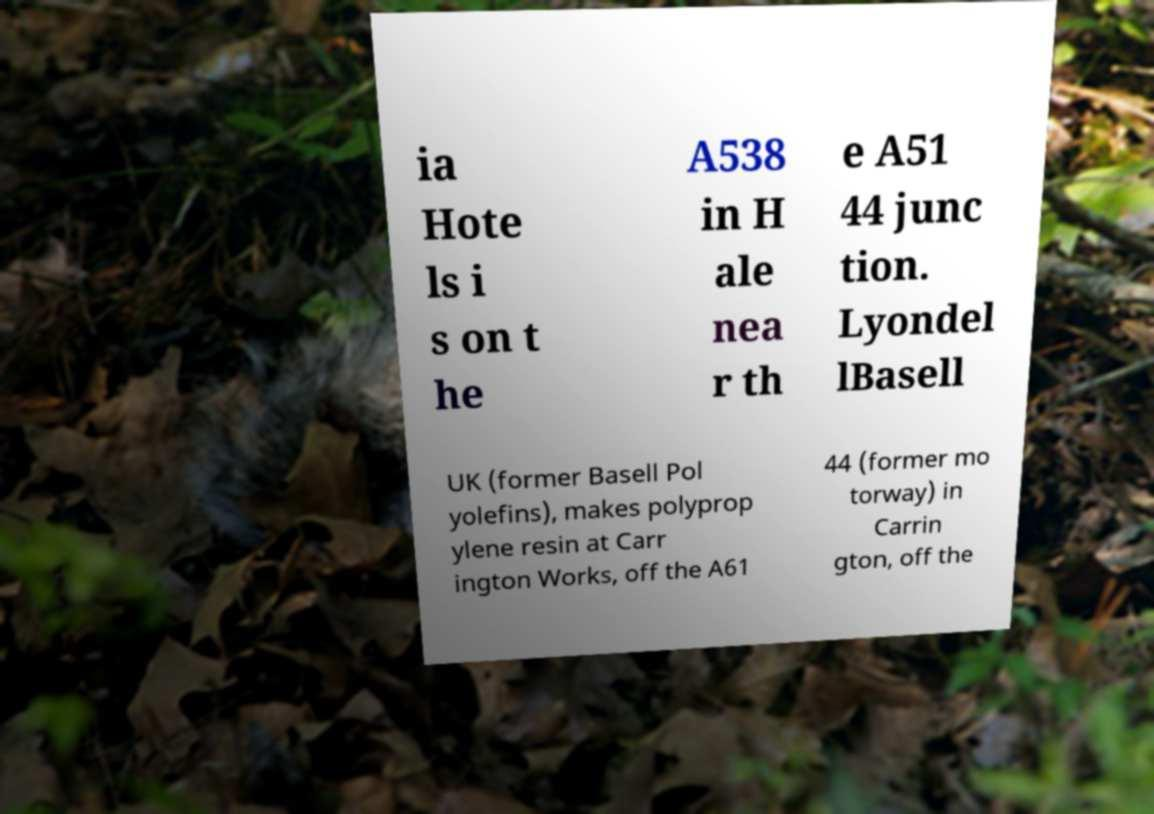I need the written content from this picture converted into text. Can you do that? ia Hote ls i s on t he A538 in H ale nea r th e A51 44 junc tion. Lyondel lBasell UK (former Basell Pol yolefins), makes polyprop ylene resin at Carr ington Works, off the A61 44 (former mo torway) in Carrin gton, off the 